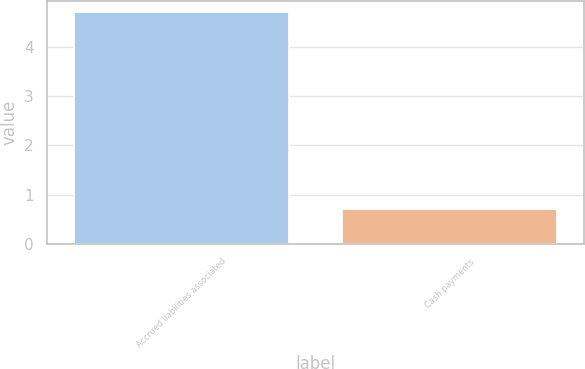<chart> <loc_0><loc_0><loc_500><loc_500><bar_chart><fcel>Accrued liabilities associated<fcel>Cash payments<nl><fcel>4.7<fcel>0.7<nl></chart> 